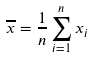Convert formula to latex. <formula><loc_0><loc_0><loc_500><loc_500>\overline { x } = \frac { 1 } { n } \sum _ { i = 1 } ^ { n } x _ { i }</formula> 